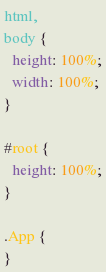Convert code to text. <code><loc_0><loc_0><loc_500><loc_500><_CSS_>html,
body {
  height: 100%;
  width: 100%;
}

#root {
  height: 100%;
}

.App {
}
</code> 